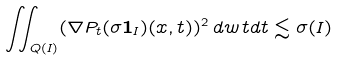Convert formula to latex. <formula><loc_0><loc_0><loc_500><loc_500>\iint _ { Q ( I ) } ( \nabla P _ { t } ( \sigma \mathbf 1 _ { I } ) ( x , t ) ) ^ { 2 } \, d w \, t d t \lesssim \sigma ( I )</formula> 